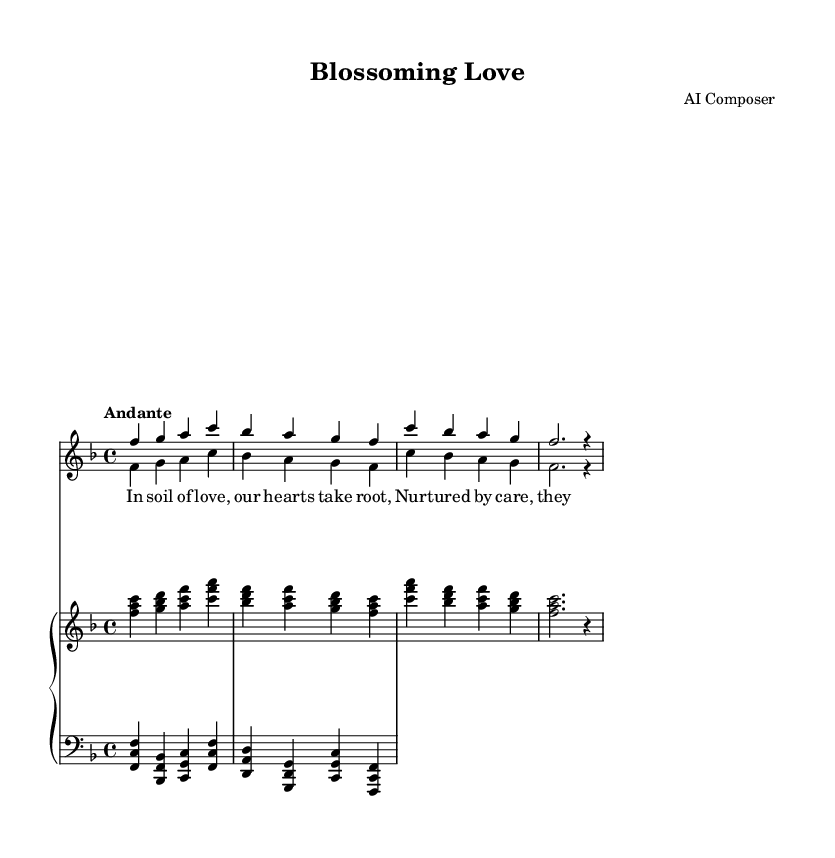What is the key signature of this music? The key signature is F major, indicated by one flat (B). You can find the key signature usually at the beginning of the staff, following the clef sign.
Answer: F major What is the time signature of this music? The time signature is 4/4, which indicates that there are four beats in each measure and a quarter note gets one beat. The time signature can be found at the beginning of the score, after the key signature.
Answer: 4/4 What is the tempo marking in this score? The tempo marking indicates that the music should be played at an "Andante" pace, which generally means a moderately slow tempo. This information is also located at the beginning of the score.
Answer: Andante How many measures are there in the soprano line? The soprano line consists of four measures, which can be counted by looking at the vertical lines that separate the measures.
Answer: Four What instruments are included in this score? The score includes vocals (soprano and tenor) and a piano accompaniment. You can identify the instruments by examining the staff labels at the beginning of each line.
Answer: Soprano, tenor, piano What thematic element is represented in the lyrics of this duet? The theme of the lyrics compares love to the growth of plants, expressing nurturing and development. To determine this, you can analyze the lyrics provided under the vocal lines.
Answer: Growth of plants Which vocal part has the lowest pitch in this composition? The lowest pitch is in the tenor part, which generally sings in a higher range than bass but lower than soprano. Analyzing the notes on the staff can help confirm this.
Answer: Tenor 